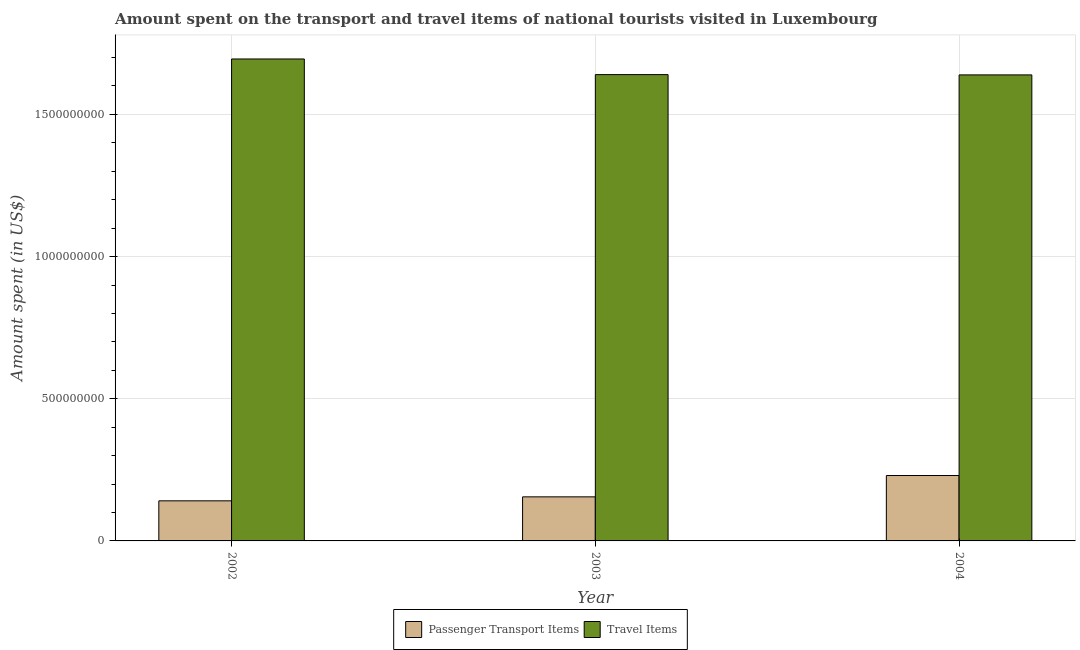How many different coloured bars are there?
Your answer should be compact. 2. Are the number of bars per tick equal to the number of legend labels?
Your answer should be very brief. Yes. How many bars are there on the 3rd tick from the left?
Give a very brief answer. 2. What is the label of the 2nd group of bars from the left?
Ensure brevity in your answer.  2003. In how many cases, is the number of bars for a given year not equal to the number of legend labels?
Keep it short and to the point. 0. What is the amount spent in travel items in 2003?
Provide a succinct answer. 1.64e+09. Across all years, what is the maximum amount spent in travel items?
Your response must be concise. 1.70e+09. Across all years, what is the minimum amount spent on passenger transport items?
Make the answer very short. 1.41e+08. In which year was the amount spent in travel items maximum?
Offer a terse response. 2002. What is the total amount spent on passenger transport items in the graph?
Keep it short and to the point. 5.26e+08. What is the difference between the amount spent in travel items in 2003 and that in 2004?
Make the answer very short. 1.00e+06. What is the difference between the amount spent in travel items in 2004 and the amount spent on passenger transport items in 2002?
Your answer should be very brief. -5.60e+07. What is the average amount spent in travel items per year?
Provide a succinct answer. 1.66e+09. In the year 2002, what is the difference between the amount spent on passenger transport items and amount spent in travel items?
Your answer should be very brief. 0. In how many years, is the amount spent on passenger transport items greater than 400000000 US$?
Ensure brevity in your answer.  0. What is the ratio of the amount spent in travel items in 2002 to that in 2004?
Provide a succinct answer. 1.03. What is the difference between the highest and the second highest amount spent in travel items?
Your answer should be very brief. 5.50e+07. What is the difference between the highest and the lowest amount spent in travel items?
Your answer should be very brief. 5.60e+07. In how many years, is the amount spent on passenger transport items greater than the average amount spent on passenger transport items taken over all years?
Offer a very short reply. 1. What does the 1st bar from the left in 2002 represents?
Ensure brevity in your answer.  Passenger Transport Items. What does the 2nd bar from the right in 2004 represents?
Your answer should be very brief. Passenger Transport Items. How many years are there in the graph?
Your response must be concise. 3. What is the title of the graph?
Keep it short and to the point. Amount spent on the transport and travel items of national tourists visited in Luxembourg. What is the label or title of the X-axis?
Your answer should be very brief. Year. What is the label or title of the Y-axis?
Make the answer very short. Amount spent (in US$). What is the Amount spent (in US$) in Passenger Transport Items in 2002?
Your response must be concise. 1.41e+08. What is the Amount spent (in US$) in Travel Items in 2002?
Your answer should be compact. 1.70e+09. What is the Amount spent (in US$) of Passenger Transport Items in 2003?
Your answer should be very brief. 1.55e+08. What is the Amount spent (in US$) in Travel Items in 2003?
Provide a succinct answer. 1.64e+09. What is the Amount spent (in US$) of Passenger Transport Items in 2004?
Provide a short and direct response. 2.30e+08. What is the Amount spent (in US$) in Travel Items in 2004?
Ensure brevity in your answer.  1.64e+09. Across all years, what is the maximum Amount spent (in US$) in Passenger Transport Items?
Your answer should be compact. 2.30e+08. Across all years, what is the maximum Amount spent (in US$) of Travel Items?
Offer a very short reply. 1.70e+09. Across all years, what is the minimum Amount spent (in US$) in Passenger Transport Items?
Provide a succinct answer. 1.41e+08. Across all years, what is the minimum Amount spent (in US$) of Travel Items?
Offer a terse response. 1.64e+09. What is the total Amount spent (in US$) in Passenger Transport Items in the graph?
Ensure brevity in your answer.  5.26e+08. What is the total Amount spent (in US$) in Travel Items in the graph?
Your response must be concise. 4.97e+09. What is the difference between the Amount spent (in US$) of Passenger Transport Items in 2002 and that in 2003?
Your answer should be compact. -1.40e+07. What is the difference between the Amount spent (in US$) in Travel Items in 2002 and that in 2003?
Offer a very short reply. 5.50e+07. What is the difference between the Amount spent (in US$) in Passenger Transport Items in 2002 and that in 2004?
Offer a very short reply. -8.90e+07. What is the difference between the Amount spent (in US$) of Travel Items in 2002 and that in 2004?
Your answer should be compact. 5.60e+07. What is the difference between the Amount spent (in US$) in Passenger Transport Items in 2003 and that in 2004?
Your answer should be very brief. -7.50e+07. What is the difference between the Amount spent (in US$) in Passenger Transport Items in 2002 and the Amount spent (in US$) in Travel Items in 2003?
Offer a terse response. -1.50e+09. What is the difference between the Amount spent (in US$) in Passenger Transport Items in 2002 and the Amount spent (in US$) in Travel Items in 2004?
Provide a succinct answer. -1.50e+09. What is the difference between the Amount spent (in US$) in Passenger Transport Items in 2003 and the Amount spent (in US$) in Travel Items in 2004?
Your answer should be very brief. -1.48e+09. What is the average Amount spent (in US$) in Passenger Transport Items per year?
Provide a succinct answer. 1.75e+08. What is the average Amount spent (in US$) in Travel Items per year?
Offer a terse response. 1.66e+09. In the year 2002, what is the difference between the Amount spent (in US$) of Passenger Transport Items and Amount spent (in US$) of Travel Items?
Provide a succinct answer. -1.55e+09. In the year 2003, what is the difference between the Amount spent (in US$) in Passenger Transport Items and Amount spent (in US$) in Travel Items?
Provide a succinct answer. -1.48e+09. In the year 2004, what is the difference between the Amount spent (in US$) of Passenger Transport Items and Amount spent (in US$) of Travel Items?
Provide a succinct answer. -1.41e+09. What is the ratio of the Amount spent (in US$) in Passenger Transport Items in 2002 to that in 2003?
Offer a very short reply. 0.91. What is the ratio of the Amount spent (in US$) in Travel Items in 2002 to that in 2003?
Provide a succinct answer. 1.03. What is the ratio of the Amount spent (in US$) of Passenger Transport Items in 2002 to that in 2004?
Your response must be concise. 0.61. What is the ratio of the Amount spent (in US$) in Travel Items in 2002 to that in 2004?
Keep it short and to the point. 1.03. What is the ratio of the Amount spent (in US$) in Passenger Transport Items in 2003 to that in 2004?
Keep it short and to the point. 0.67. What is the ratio of the Amount spent (in US$) in Travel Items in 2003 to that in 2004?
Offer a terse response. 1. What is the difference between the highest and the second highest Amount spent (in US$) in Passenger Transport Items?
Your answer should be compact. 7.50e+07. What is the difference between the highest and the second highest Amount spent (in US$) in Travel Items?
Keep it short and to the point. 5.50e+07. What is the difference between the highest and the lowest Amount spent (in US$) in Passenger Transport Items?
Offer a terse response. 8.90e+07. What is the difference between the highest and the lowest Amount spent (in US$) in Travel Items?
Keep it short and to the point. 5.60e+07. 